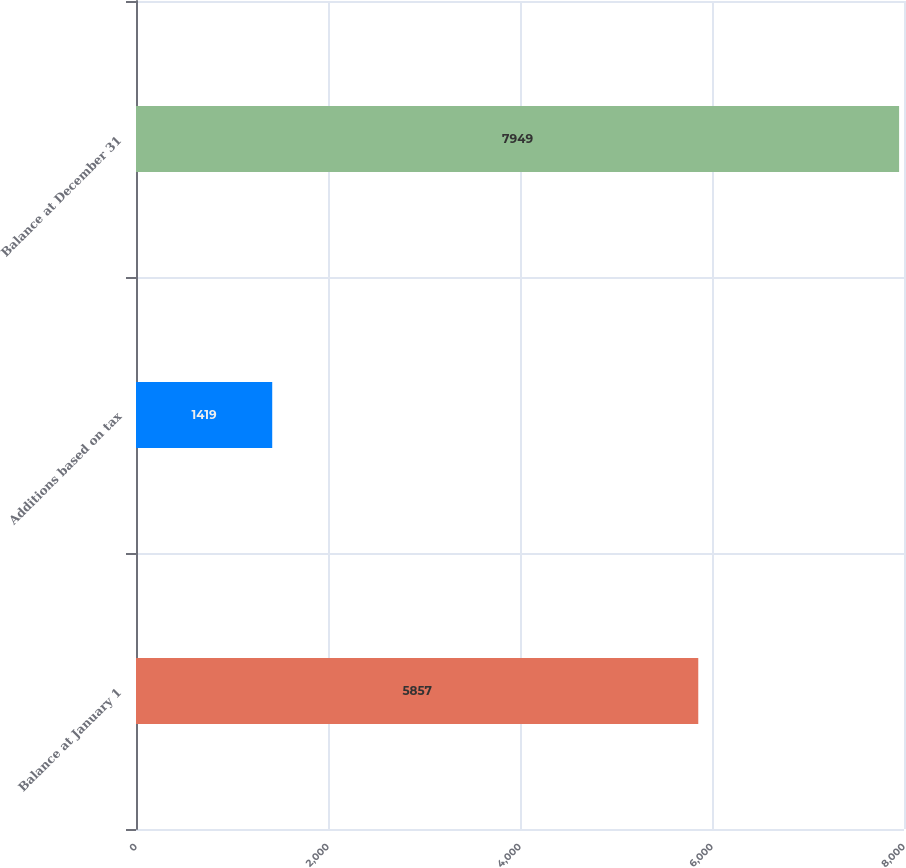<chart> <loc_0><loc_0><loc_500><loc_500><bar_chart><fcel>Balance at January 1<fcel>Additions based on tax<fcel>Balance at December 31<nl><fcel>5857<fcel>1419<fcel>7949<nl></chart> 